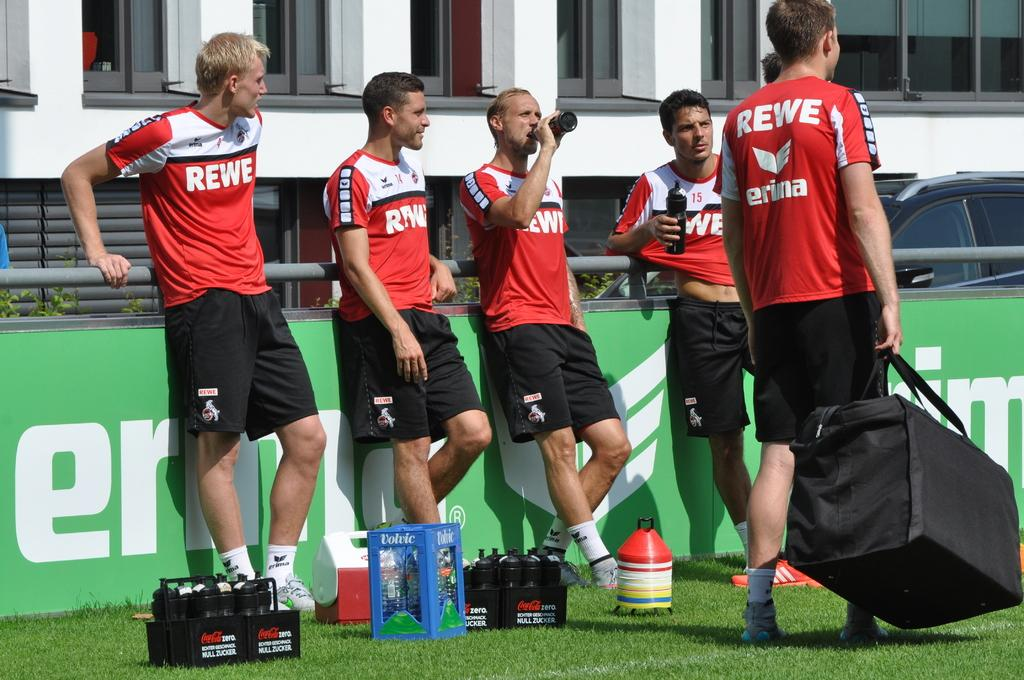<image>
Present a compact description of the photo's key features. Members of the team Rewe are standing around drinking water. 